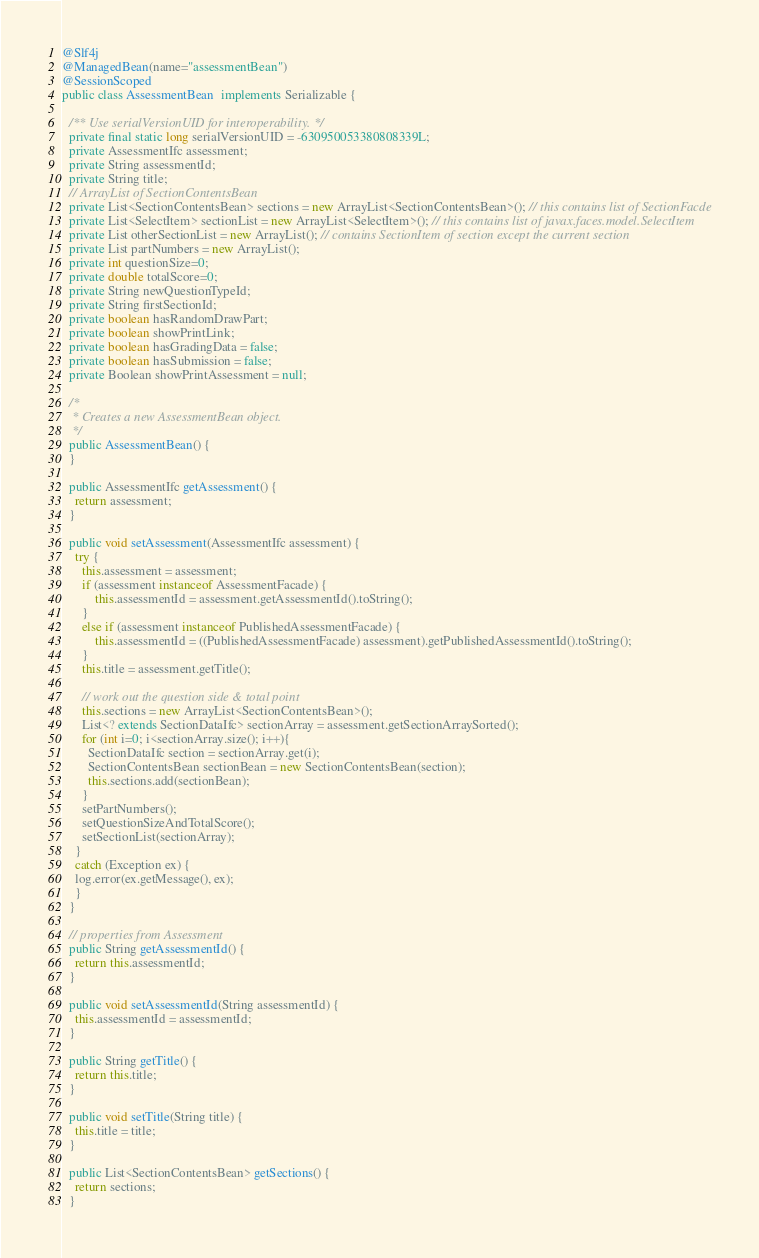Convert code to text. <code><loc_0><loc_0><loc_500><loc_500><_Java_>@Slf4j
@ManagedBean(name="assessmentBean")
@SessionScoped
public class AssessmentBean  implements Serializable {

  /** Use serialVersionUID for interoperability. */
  private final static long serialVersionUID = -630950053380808339L;
  private AssessmentIfc assessment;
  private String assessmentId;
  private String title;
  // ArrayList of SectionContentsBean
  private List<SectionContentsBean> sections = new ArrayList<SectionContentsBean>(); // this contains list of SectionFacde
  private List<SelectItem> sectionList = new ArrayList<SelectItem>(); // this contains list of javax.faces.model.SelectItem
  private List otherSectionList = new ArrayList(); // contains SectionItem of section except the current section
  private List partNumbers = new ArrayList();
  private int questionSize=0;
  private double totalScore=0;
  private String newQuestionTypeId;
  private String firstSectionId;
  private boolean hasRandomDrawPart;
  private boolean showPrintLink;
  private boolean hasGradingData = false;
  private boolean hasSubmission = false;
  private Boolean showPrintAssessment = null;

  /*
   * Creates a new AssessmentBean object.
   */
  public AssessmentBean() {
  }

  public AssessmentIfc getAssessment() {
    return assessment;
  }

  public void setAssessment(AssessmentIfc assessment) {
    try {
      this.assessment = assessment;
      if (assessment instanceof AssessmentFacade) {
    	  this.assessmentId = assessment.getAssessmentId().toString();
      }
      else if (assessment instanceof PublishedAssessmentFacade) {
    	  this.assessmentId = ((PublishedAssessmentFacade) assessment).getPublishedAssessmentId().toString();
      }
      this.title = assessment.getTitle();

      // work out the question side & total point
      this.sections = new ArrayList<SectionContentsBean>();
      List<? extends SectionDataIfc> sectionArray = assessment.getSectionArraySorted();
      for (int i=0; i<sectionArray.size(); i++){
        SectionDataIfc section = sectionArray.get(i);
        SectionContentsBean sectionBean = new SectionContentsBean(section);
        this.sections.add(sectionBean);
      }
      setPartNumbers();
      setQuestionSizeAndTotalScore();
      setSectionList(sectionArray);
    }
    catch (Exception ex) {
	log.error(ex.getMessage(), ex);
    }
  }

  // properties from Assessment
  public String getAssessmentId() {
    return this.assessmentId;
  }

  public void setAssessmentId(String assessmentId) {
    this.assessmentId = assessmentId;
  }

  public String getTitle() {
    return this.title;
  }

  public void setTitle(String title) {
    this.title = title;
  }

  public List<SectionContentsBean> getSections() {
    return sections;
  }
</code> 